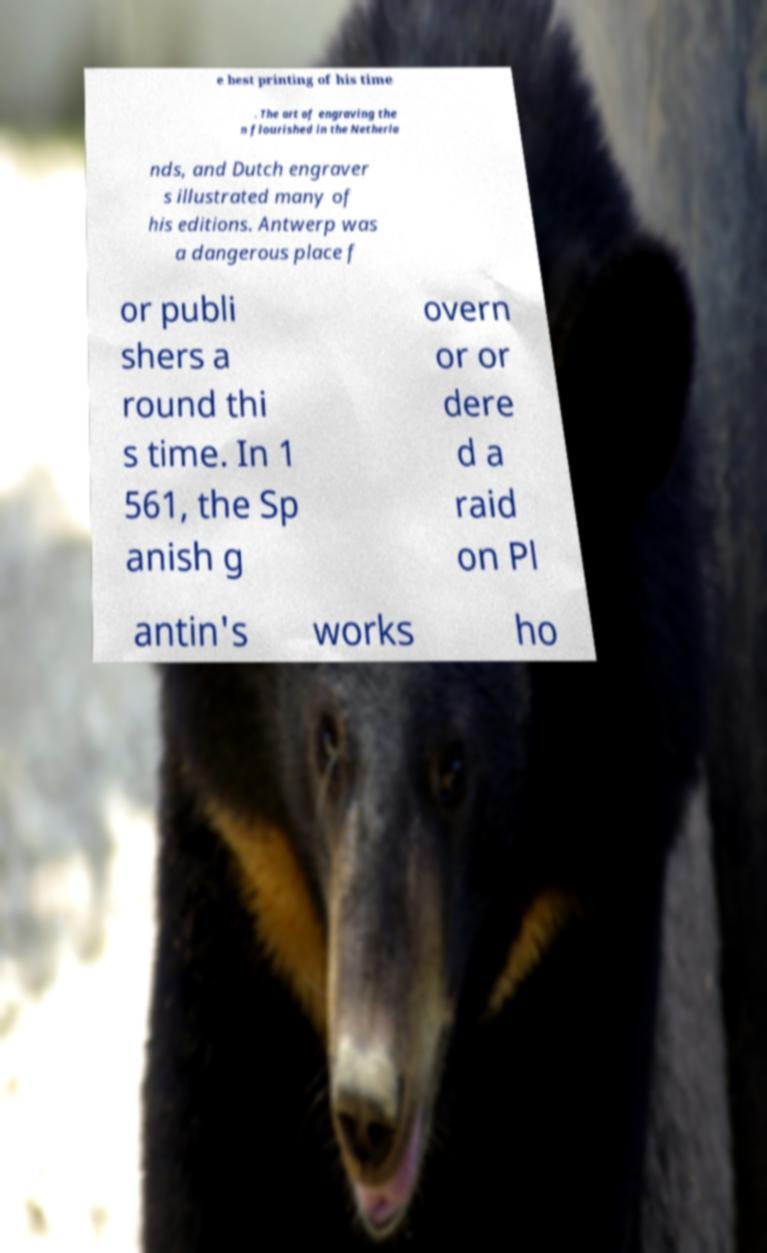Can you accurately transcribe the text from the provided image for me? e best printing of his time . The art of engraving the n flourished in the Netherla nds, and Dutch engraver s illustrated many of his editions. Antwerp was a dangerous place f or publi shers a round thi s time. In 1 561, the Sp anish g overn or or dere d a raid on Pl antin's works ho 